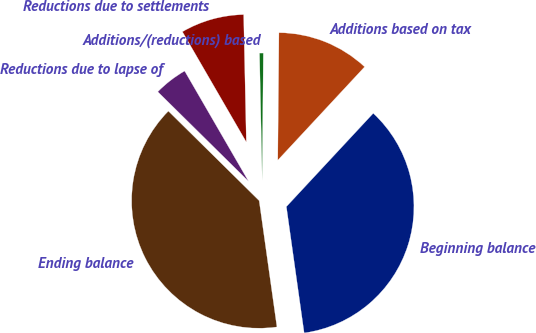<chart> <loc_0><loc_0><loc_500><loc_500><pie_chart><fcel>Beginning balance<fcel>Additions based on tax<fcel>Additions/(reductions) based<fcel>Reductions due to settlements<fcel>Reductions due to lapse of<fcel>Ending balance<nl><fcel>35.85%<fcel>11.78%<fcel>0.48%<fcel>8.02%<fcel>4.25%<fcel>39.62%<nl></chart> 